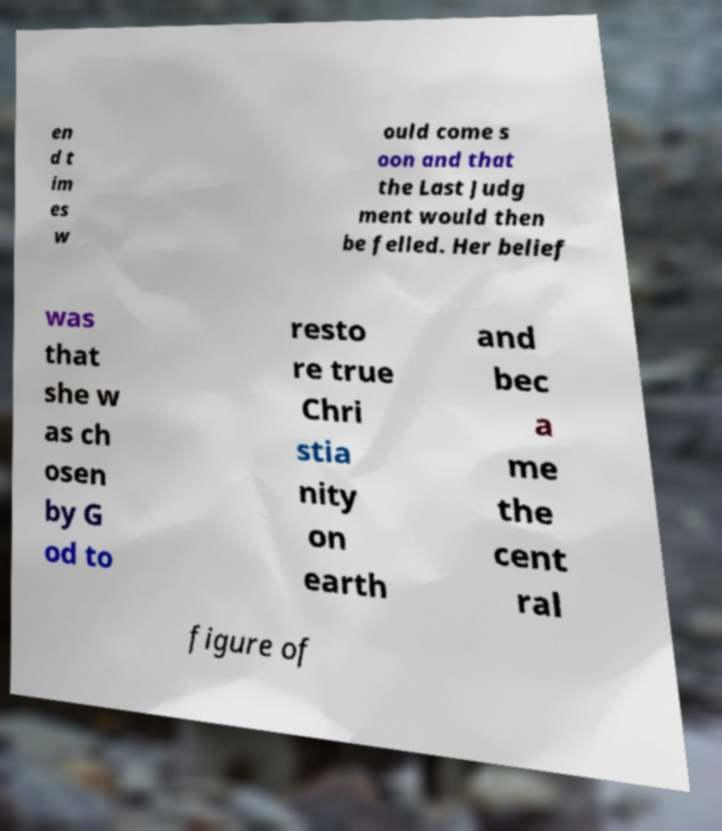For documentation purposes, I need the text within this image transcribed. Could you provide that? en d t im es w ould come s oon and that the Last Judg ment would then be felled. Her belief was that she w as ch osen by G od to resto re true Chri stia nity on earth and bec a me the cent ral figure of 